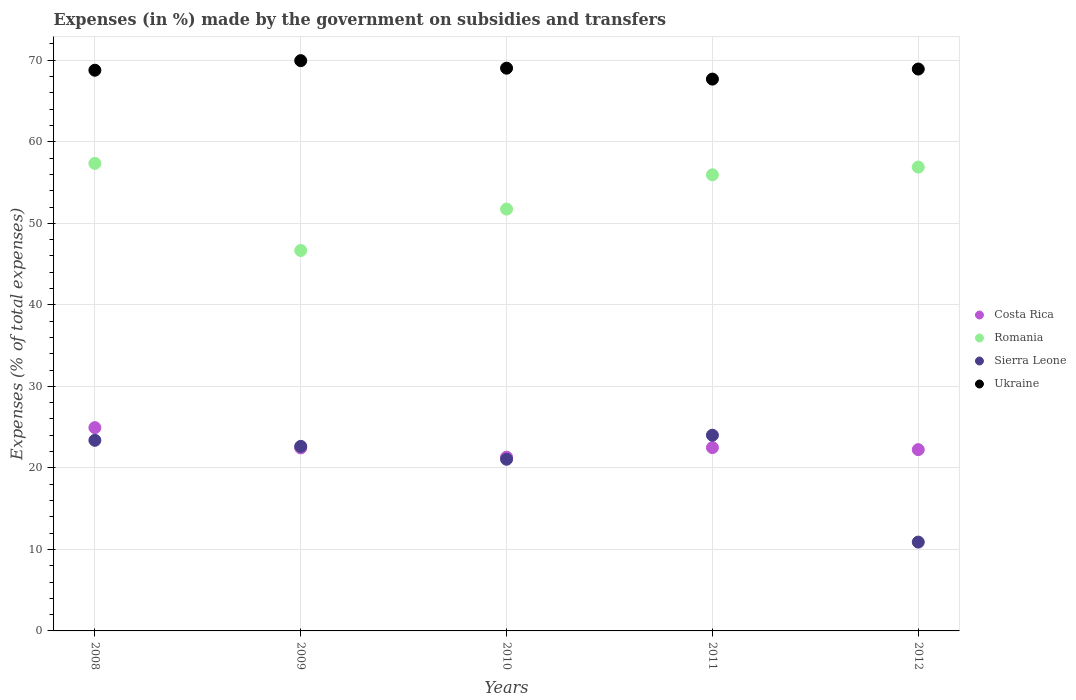What is the percentage of expenses made by the government on subsidies and transfers in Costa Rica in 2009?
Your answer should be compact. 22.45. Across all years, what is the maximum percentage of expenses made by the government on subsidies and transfers in Costa Rica?
Your answer should be compact. 24.94. Across all years, what is the minimum percentage of expenses made by the government on subsidies and transfers in Romania?
Your answer should be compact. 46.67. What is the total percentage of expenses made by the government on subsidies and transfers in Sierra Leone in the graph?
Provide a succinct answer. 101.99. What is the difference between the percentage of expenses made by the government on subsidies and transfers in Romania in 2008 and that in 2011?
Offer a terse response. 1.4. What is the difference between the percentage of expenses made by the government on subsidies and transfers in Sierra Leone in 2011 and the percentage of expenses made by the government on subsidies and transfers in Romania in 2009?
Provide a short and direct response. -22.66. What is the average percentage of expenses made by the government on subsidies and transfers in Ukraine per year?
Offer a terse response. 68.88. In the year 2012, what is the difference between the percentage of expenses made by the government on subsidies and transfers in Sierra Leone and percentage of expenses made by the government on subsidies and transfers in Romania?
Provide a short and direct response. -46. In how many years, is the percentage of expenses made by the government on subsidies and transfers in Romania greater than 14 %?
Offer a very short reply. 5. What is the ratio of the percentage of expenses made by the government on subsidies and transfers in Ukraine in 2011 to that in 2012?
Make the answer very short. 0.98. Is the percentage of expenses made by the government on subsidies and transfers in Ukraine in 2008 less than that in 2011?
Provide a short and direct response. No. What is the difference between the highest and the second highest percentage of expenses made by the government on subsidies and transfers in Sierra Leone?
Keep it short and to the point. 0.62. What is the difference between the highest and the lowest percentage of expenses made by the government on subsidies and transfers in Costa Rica?
Provide a short and direct response. 3.62. Is it the case that in every year, the sum of the percentage of expenses made by the government on subsidies and transfers in Ukraine and percentage of expenses made by the government on subsidies and transfers in Costa Rica  is greater than the sum of percentage of expenses made by the government on subsidies and transfers in Sierra Leone and percentage of expenses made by the government on subsidies and transfers in Romania?
Ensure brevity in your answer.  No. Is it the case that in every year, the sum of the percentage of expenses made by the government on subsidies and transfers in Costa Rica and percentage of expenses made by the government on subsidies and transfers in Romania  is greater than the percentage of expenses made by the government on subsidies and transfers in Ukraine?
Provide a short and direct response. No. Does the percentage of expenses made by the government on subsidies and transfers in Costa Rica monotonically increase over the years?
Your response must be concise. No. Is the percentage of expenses made by the government on subsidies and transfers in Sierra Leone strictly greater than the percentage of expenses made by the government on subsidies and transfers in Ukraine over the years?
Ensure brevity in your answer.  No. Is the percentage of expenses made by the government on subsidies and transfers in Costa Rica strictly less than the percentage of expenses made by the government on subsidies and transfers in Ukraine over the years?
Ensure brevity in your answer.  Yes. How many years are there in the graph?
Make the answer very short. 5. What is the difference between two consecutive major ticks on the Y-axis?
Your response must be concise. 10. Are the values on the major ticks of Y-axis written in scientific E-notation?
Give a very brief answer. No. Where does the legend appear in the graph?
Your answer should be very brief. Center right. What is the title of the graph?
Ensure brevity in your answer.  Expenses (in %) made by the government on subsidies and transfers. Does "Central Europe" appear as one of the legend labels in the graph?
Give a very brief answer. No. What is the label or title of the Y-axis?
Give a very brief answer. Expenses (% of total expenses). What is the Expenses (% of total expenses) in Costa Rica in 2008?
Ensure brevity in your answer.  24.94. What is the Expenses (% of total expenses) of Romania in 2008?
Offer a very short reply. 57.35. What is the Expenses (% of total expenses) of Sierra Leone in 2008?
Keep it short and to the point. 23.38. What is the Expenses (% of total expenses) of Ukraine in 2008?
Provide a short and direct response. 68.78. What is the Expenses (% of total expenses) in Costa Rica in 2009?
Your answer should be very brief. 22.45. What is the Expenses (% of total expenses) in Romania in 2009?
Give a very brief answer. 46.67. What is the Expenses (% of total expenses) in Sierra Leone in 2009?
Your response must be concise. 22.64. What is the Expenses (% of total expenses) of Ukraine in 2009?
Keep it short and to the point. 69.96. What is the Expenses (% of total expenses) in Costa Rica in 2010?
Give a very brief answer. 21.31. What is the Expenses (% of total expenses) of Romania in 2010?
Your answer should be compact. 51.75. What is the Expenses (% of total expenses) of Sierra Leone in 2010?
Give a very brief answer. 21.06. What is the Expenses (% of total expenses) in Ukraine in 2010?
Offer a very short reply. 69.03. What is the Expenses (% of total expenses) of Costa Rica in 2011?
Your response must be concise. 22.49. What is the Expenses (% of total expenses) of Romania in 2011?
Provide a short and direct response. 55.95. What is the Expenses (% of total expenses) of Sierra Leone in 2011?
Offer a very short reply. 24.01. What is the Expenses (% of total expenses) of Ukraine in 2011?
Provide a short and direct response. 67.69. What is the Expenses (% of total expenses) in Costa Rica in 2012?
Keep it short and to the point. 22.24. What is the Expenses (% of total expenses) in Romania in 2012?
Provide a short and direct response. 56.9. What is the Expenses (% of total expenses) in Sierra Leone in 2012?
Ensure brevity in your answer.  10.9. What is the Expenses (% of total expenses) of Ukraine in 2012?
Your answer should be very brief. 68.93. Across all years, what is the maximum Expenses (% of total expenses) of Costa Rica?
Provide a succinct answer. 24.94. Across all years, what is the maximum Expenses (% of total expenses) in Romania?
Ensure brevity in your answer.  57.35. Across all years, what is the maximum Expenses (% of total expenses) of Sierra Leone?
Give a very brief answer. 24.01. Across all years, what is the maximum Expenses (% of total expenses) of Ukraine?
Your answer should be compact. 69.96. Across all years, what is the minimum Expenses (% of total expenses) in Costa Rica?
Your answer should be compact. 21.31. Across all years, what is the minimum Expenses (% of total expenses) of Romania?
Offer a very short reply. 46.67. Across all years, what is the minimum Expenses (% of total expenses) of Sierra Leone?
Offer a very short reply. 10.9. Across all years, what is the minimum Expenses (% of total expenses) in Ukraine?
Provide a succinct answer. 67.69. What is the total Expenses (% of total expenses) of Costa Rica in the graph?
Make the answer very short. 113.43. What is the total Expenses (% of total expenses) in Romania in the graph?
Offer a very short reply. 268.61. What is the total Expenses (% of total expenses) of Sierra Leone in the graph?
Offer a very short reply. 101.99. What is the total Expenses (% of total expenses) in Ukraine in the graph?
Offer a very short reply. 344.38. What is the difference between the Expenses (% of total expenses) in Costa Rica in 2008 and that in 2009?
Your answer should be very brief. 2.49. What is the difference between the Expenses (% of total expenses) of Romania in 2008 and that in 2009?
Give a very brief answer. 10.68. What is the difference between the Expenses (% of total expenses) of Sierra Leone in 2008 and that in 2009?
Offer a very short reply. 0.74. What is the difference between the Expenses (% of total expenses) in Ukraine in 2008 and that in 2009?
Offer a terse response. -1.17. What is the difference between the Expenses (% of total expenses) in Costa Rica in 2008 and that in 2010?
Your answer should be very brief. 3.62. What is the difference between the Expenses (% of total expenses) in Romania in 2008 and that in 2010?
Give a very brief answer. 5.6. What is the difference between the Expenses (% of total expenses) of Sierra Leone in 2008 and that in 2010?
Keep it short and to the point. 2.32. What is the difference between the Expenses (% of total expenses) of Ukraine in 2008 and that in 2010?
Ensure brevity in your answer.  -0.25. What is the difference between the Expenses (% of total expenses) in Costa Rica in 2008 and that in 2011?
Make the answer very short. 2.45. What is the difference between the Expenses (% of total expenses) of Romania in 2008 and that in 2011?
Offer a terse response. 1.4. What is the difference between the Expenses (% of total expenses) in Sierra Leone in 2008 and that in 2011?
Your answer should be very brief. -0.62. What is the difference between the Expenses (% of total expenses) in Ukraine in 2008 and that in 2011?
Your answer should be very brief. 1.09. What is the difference between the Expenses (% of total expenses) in Costa Rica in 2008 and that in 2012?
Your answer should be compact. 2.7. What is the difference between the Expenses (% of total expenses) in Romania in 2008 and that in 2012?
Your answer should be compact. 0.45. What is the difference between the Expenses (% of total expenses) of Sierra Leone in 2008 and that in 2012?
Provide a succinct answer. 12.49. What is the difference between the Expenses (% of total expenses) in Ukraine in 2008 and that in 2012?
Ensure brevity in your answer.  -0.15. What is the difference between the Expenses (% of total expenses) of Costa Rica in 2009 and that in 2010?
Ensure brevity in your answer.  1.14. What is the difference between the Expenses (% of total expenses) in Romania in 2009 and that in 2010?
Your response must be concise. -5.08. What is the difference between the Expenses (% of total expenses) in Sierra Leone in 2009 and that in 2010?
Give a very brief answer. 1.58. What is the difference between the Expenses (% of total expenses) in Ukraine in 2009 and that in 2010?
Offer a very short reply. 0.92. What is the difference between the Expenses (% of total expenses) of Costa Rica in 2009 and that in 2011?
Your answer should be very brief. -0.04. What is the difference between the Expenses (% of total expenses) of Romania in 2009 and that in 2011?
Keep it short and to the point. -9.29. What is the difference between the Expenses (% of total expenses) of Sierra Leone in 2009 and that in 2011?
Your response must be concise. -1.36. What is the difference between the Expenses (% of total expenses) of Ukraine in 2009 and that in 2011?
Offer a very short reply. 2.26. What is the difference between the Expenses (% of total expenses) in Costa Rica in 2009 and that in 2012?
Keep it short and to the point. 0.21. What is the difference between the Expenses (% of total expenses) of Romania in 2009 and that in 2012?
Your answer should be compact. -10.23. What is the difference between the Expenses (% of total expenses) of Sierra Leone in 2009 and that in 2012?
Your response must be concise. 11.74. What is the difference between the Expenses (% of total expenses) of Ukraine in 2009 and that in 2012?
Your response must be concise. 1.03. What is the difference between the Expenses (% of total expenses) in Costa Rica in 2010 and that in 2011?
Make the answer very short. -1.17. What is the difference between the Expenses (% of total expenses) in Romania in 2010 and that in 2011?
Your answer should be very brief. -4.2. What is the difference between the Expenses (% of total expenses) of Sierra Leone in 2010 and that in 2011?
Give a very brief answer. -2.95. What is the difference between the Expenses (% of total expenses) in Ukraine in 2010 and that in 2011?
Ensure brevity in your answer.  1.34. What is the difference between the Expenses (% of total expenses) in Costa Rica in 2010 and that in 2012?
Give a very brief answer. -0.92. What is the difference between the Expenses (% of total expenses) of Romania in 2010 and that in 2012?
Your response must be concise. -5.15. What is the difference between the Expenses (% of total expenses) of Sierra Leone in 2010 and that in 2012?
Provide a succinct answer. 10.16. What is the difference between the Expenses (% of total expenses) of Ukraine in 2010 and that in 2012?
Your answer should be compact. 0.11. What is the difference between the Expenses (% of total expenses) in Costa Rica in 2011 and that in 2012?
Ensure brevity in your answer.  0.25. What is the difference between the Expenses (% of total expenses) in Romania in 2011 and that in 2012?
Make the answer very short. -0.94. What is the difference between the Expenses (% of total expenses) of Sierra Leone in 2011 and that in 2012?
Your answer should be very brief. 13.11. What is the difference between the Expenses (% of total expenses) of Ukraine in 2011 and that in 2012?
Provide a succinct answer. -1.23. What is the difference between the Expenses (% of total expenses) of Costa Rica in 2008 and the Expenses (% of total expenses) of Romania in 2009?
Offer a terse response. -21.73. What is the difference between the Expenses (% of total expenses) of Costa Rica in 2008 and the Expenses (% of total expenses) of Sierra Leone in 2009?
Your response must be concise. 2.3. What is the difference between the Expenses (% of total expenses) of Costa Rica in 2008 and the Expenses (% of total expenses) of Ukraine in 2009?
Ensure brevity in your answer.  -45.02. What is the difference between the Expenses (% of total expenses) of Romania in 2008 and the Expenses (% of total expenses) of Sierra Leone in 2009?
Your response must be concise. 34.71. What is the difference between the Expenses (% of total expenses) in Romania in 2008 and the Expenses (% of total expenses) in Ukraine in 2009?
Ensure brevity in your answer.  -12.61. What is the difference between the Expenses (% of total expenses) in Sierra Leone in 2008 and the Expenses (% of total expenses) in Ukraine in 2009?
Ensure brevity in your answer.  -46.57. What is the difference between the Expenses (% of total expenses) in Costa Rica in 2008 and the Expenses (% of total expenses) in Romania in 2010?
Provide a short and direct response. -26.81. What is the difference between the Expenses (% of total expenses) in Costa Rica in 2008 and the Expenses (% of total expenses) in Sierra Leone in 2010?
Make the answer very short. 3.88. What is the difference between the Expenses (% of total expenses) of Costa Rica in 2008 and the Expenses (% of total expenses) of Ukraine in 2010?
Provide a succinct answer. -44.09. What is the difference between the Expenses (% of total expenses) in Romania in 2008 and the Expenses (% of total expenses) in Sierra Leone in 2010?
Your answer should be very brief. 36.29. What is the difference between the Expenses (% of total expenses) in Romania in 2008 and the Expenses (% of total expenses) in Ukraine in 2010?
Provide a short and direct response. -11.68. What is the difference between the Expenses (% of total expenses) in Sierra Leone in 2008 and the Expenses (% of total expenses) in Ukraine in 2010?
Give a very brief answer. -45.65. What is the difference between the Expenses (% of total expenses) in Costa Rica in 2008 and the Expenses (% of total expenses) in Romania in 2011?
Your answer should be very brief. -31.01. What is the difference between the Expenses (% of total expenses) of Costa Rica in 2008 and the Expenses (% of total expenses) of Sierra Leone in 2011?
Keep it short and to the point. 0.93. What is the difference between the Expenses (% of total expenses) of Costa Rica in 2008 and the Expenses (% of total expenses) of Ukraine in 2011?
Provide a short and direct response. -42.75. What is the difference between the Expenses (% of total expenses) in Romania in 2008 and the Expenses (% of total expenses) in Sierra Leone in 2011?
Your answer should be very brief. 33.34. What is the difference between the Expenses (% of total expenses) in Romania in 2008 and the Expenses (% of total expenses) in Ukraine in 2011?
Make the answer very short. -10.34. What is the difference between the Expenses (% of total expenses) in Sierra Leone in 2008 and the Expenses (% of total expenses) in Ukraine in 2011?
Offer a very short reply. -44.31. What is the difference between the Expenses (% of total expenses) of Costa Rica in 2008 and the Expenses (% of total expenses) of Romania in 2012?
Keep it short and to the point. -31.96. What is the difference between the Expenses (% of total expenses) of Costa Rica in 2008 and the Expenses (% of total expenses) of Sierra Leone in 2012?
Provide a short and direct response. 14.04. What is the difference between the Expenses (% of total expenses) in Costa Rica in 2008 and the Expenses (% of total expenses) in Ukraine in 2012?
Make the answer very short. -43.99. What is the difference between the Expenses (% of total expenses) of Romania in 2008 and the Expenses (% of total expenses) of Sierra Leone in 2012?
Provide a succinct answer. 46.45. What is the difference between the Expenses (% of total expenses) in Romania in 2008 and the Expenses (% of total expenses) in Ukraine in 2012?
Your answer should be compact. -11.58. What is the difference between the Expenses (% of total expenses) in Sierra Leone in 2008 and the Expenses (% of total expenses) in Ukraine in 2012?
Offer a terse response. -45.54. What is the difference between the Expenses (% of total expenses) of Costa Rica in 2009 and the Expenses (% of total expenses) of Romania in 2010?
Make the answer very short. -29.3. What is the difference between the Expenses (% of total expenses) of Costa Rica in 2009 and the Expenses (% of total expenses) of Sierra Leone in 2010?
Your answer should be very brief. 1.39. What is the difference between the Expenses (% of total expenses) of Costa Rica in 2009 and the Expenses (% of total expenses) of Ukraine in 2010?
Provide a succinct answer. -46.58. What is the difference between the Expenses (% of total expenses) in Romania in 2009 and the Expenses (% of total expenses) in Sierra Leone in 2010?
Your answer should be very brief. 25.61. What is the difference between the Expenses (% of total expenses) in Romania in 2009 and the Expenses (% of total expenses) in Ukraine in 2010?
Your answer should be compact. -22.37. What is the difference between the Expenses (% of total expenses) in Sierra Leone in 2009 and the Expenses (% of total expenses) in Ukraine in 2010?
Ensure brevity in your answer.  -46.39. What is the difference between the Expenses (% of total expenses) in Costa Rica in 2009 and the Expenses (% of total expenses) in Romania in 2011?
Offer a very short reply. -33.5. What is the difference between the Expenses (% of total expenses) of Costa Rica in 2009 and the Expenses (% of total expenses) of Sierra Leone in 2011?
Offer a very short reply. -1.55. What is the difference between the Expenses (% of total expenses) of Costa Rica in 2009 and the Expenses (% of total expenses) of Ukraine in 2011?
Offer a terse response. -45.24. What is the difference between the Expenses (% of total expenses) in Romania in 2009 and the Expenses (% of total expenses) in Sierra Leone in 2011?
Your answer should be very brief. 22.66. What is the difference between the Expenses (% of total expenses) in Romania in 2009 and the Expenses (% of total expenses) in Ukraine in 2011?
Your response must be concise. -21.03. What is the difference between the Expenses (% of total expenses) of Sierra Leone in 2009 and the Expenses (% of total expenses) of Ukraine in 2011?
Keep it short and to the point. -45.05. What is the difference between the Expenses (% of total expenses) in Costa Rica in 2009 and the Expenses (% of total expenses) in Romania in 2012?
Your answer should be very brief. -34.45. What is the difference between the Expenses (% of total expenses) in Costa Rica in 2009 and the Expenses (% of total expenses) in Sierra Leone in 2012?
Give a very brief answer. 11.55. What is the difference between the Expenses (% of total expenses) in Costa Rica in 2009 and the Expenses (% of total expenses) in Ukraine in 2012?
Provide a short and direct response. -46.47. What is the difference between the Expenses (% of total expenses) in Romania in 2009 and the Expenses (% of total expenses) in Sierra Leone in 2012?
Ensure brevity in your answer.  35.77. What is the difference between the Expenses (% of total expenses) in Romania in 2009 and the Expenses (% of total expenses) in Ukraine in 2012?
Give a very brief answer. -22.26. What is the difference between the Expenses (% of total expenses) in Sierra Leone in 2009 and the Expenses (% of total expenses) in Ukraine in 2012?
Make the answer very short. -46.28. What is the difference between the Expenses (% of total expenses) in Costa Rica in 2010 and the Expenses (% of total expenses) in Romania in 2011?
Offer a terse response. -34.64. What is the difference between the Expenses (% of total expenses) of Costa Rica in 2010 and the Expenses (% of total expenses) of Sierra Leone in 2011?
Give a very brief answer. -2.69. What is the difference between the Expenses (% of total expenses) in Costa Rica in 2010 and the Expenses (% of total expenses) in Ukraine in 2011?
Provide a short and direct response. -46.38. What is the difference between the Expenses (% of total expenses) of Romania in 2010 and the Expenses (% of total expenses) of Sierra Leone in 2011?
Give a very brief answer. 27.74. What is the difference between the Expenses (% of total expenses) of Romania in 2010 and the Expenses (% of total expenses) of Ukraine in 2011?
Make the answer very short. -15.94. What is the difference between the Expenses (% of total expenses) of Sierra Leone in 2010 and the Expenses (% of total expenses) of Ukraine in 2011?
Give a very brief answer. -46.63. What is the difference between the Expenses (% of total expenses) of Costa Rica in 2010 and the Expenses (% of total expenses) of Romania in 2012?
Make the answer very short. -35.58. What is the difference between the Expenses (% of total expenses) in Costa Rica in 2010 and the Expenses (% of total expenses) in Sierra Leone in 2012?
Your answer should be very brief. 10.42. What is the difference between the Expenses (% of total expenses) of Costa Rica in 2010 and the Expenses (% of total expenses) of Ukraine in 2012?
Your answer should be very brief. -47.61. What is the difference between the Expenses (% of total expenses) in Romania in 2010 and the Expenses (% of total expenses) in Sierra Leone in 2012?
Offer a very short reply. 40.85. What is the difference between the Expenses (% of total expenses) of Romania in 2010 and the Expenses (% of total expenses) of Ukraine in 2012?
Provide a succinct answer. -17.18. What is the difference between the Expenses (% of total expenses) of Sierra Leone in 2010 and the Expenses (% of total expenses) of Ukraine in 2012?
Provide a short and direct response. -47.87. What is the difference between the Expenses (% of total expenses) of Costa Rica in 2011 and the Expenses (% of total expenses) of Romania in 2012?
Your response must be concise. -34.41. What is the difference between the Expenses (% of total expenses) of Costa Rica in 2011 and the Expenses (% of total expenses) of Sierra Leone in 2012?
Your answer should be very brief. 11.59. What is the difference between the Expenses (% of total expenses) of Costa Rica in 2011 and the Expenses (% of total expenses) of Ukraine in 2012?
Ensure brevity in your answer.  -46.44. What is the difference between the Expenses (% of total expenses) in Romania in 2011 and the Expenses (% of total expenses) in Sierra Leone in 2012?
Give a very brief answer. 45.06. What is the difference between the Expenses (% of total expenses) in Romania in 2011 and the Expenses (% of total expenses) in Ukraine in 2012?
Give a very brief answer. -12.97. What is the difference between the Expenses (% of total expenses) in Sierra Leone in 2011 and the Expenses (% of total expenses) in Ukraine in 2012?
Give a very brief answer. -44.92. What is the average Expenses (% of total expenses) in Costa Rica per year?
Provide a succinct answer. 22.69. What is the average Expenses (% of total expenses) of Romania per year?
Offer a very short reply. 53.72. What is the average Expenses (% of total expenses) of Sierra Leone per year?
Offer a very short reply. 20.4. What is the average Expenses (% of total expenses) in Ukraine per year?
Offer a very short reply. 68.88. In the year 2008, what is the difference between the Expenses (% of total expenses) in Costa Rica and Expenses (% of total expenses) in Romania?
Give a very brief answer. -32.41. In the year 2008, what is the difference between the Expenses (% of total expenses) of Costa Rica and Expenses (% of total expenses) of Sierra Leone?
Give a very brief answer. 1.56. In the year 2008, what is the difference between the Expenses (% of total expenses) in Costa Rica and Expenses (% of total expenses) in Ukraine?
Provide a succinct answer. -43.84. In the year 2008, what is the difference between the Expenses (% of total expenses) in Romania and Expenses (% of total expenses) in Sierra Leone?
Give a very brief answer. 33.97. In the year 2008, what is the difference between the Expenses (% of total expenses) in Romania and Expenses (% of total expenses) in Ukraine?
Your answer should be very brief. -11.43. In the year 2008, what is the difference between the Expenses (% of total expenses) of Sierra Leone and Expenses (% of total expenses) of Ukraine?
Provide a succinct answer. -45.4. In the year 2009, what is the difference between the Expenses (% of total expenses) of Costa Rica and Expenses (% of total expenses) of Romania?
Provide a short and direct response. -24.21. In the year 2009, what is the difference between the Expenses (% of total expenses) of Costa Rica and Expenses (% of total expenses) of Sierra Leone?
Your response must be concise. -0.19. In the year 2009, what is the difference between the Expenses (% of total expenses) of Costa Rica and Expenses (% of total expenses) of Ukraine?
Keep it short and to the point. -47.5. In the year 2009, what is the difference between the Expenses (% of total expenses) in Romania and Expenses (% of total expenses) in Sierra Leone?
Your answer should be compact. 24.02. In the year 2009, what is the difference between the Expenses (% of total expenses) of Romania and Expenses (% of total expenses) of Ukraine?
Offer a terse response. -23.29. In the year 2009, what is the difference between the Expenses (% of total expenses) of Sierra Leone and Expenses (% of total expenses) of Ukraine?
Ensure brevity in your answer.  -47.31. In the year 2010, what is the difference between the Expenses (% of total expenses) in Costa Rica and Expenses (% of total expenses) in Romania?
Keep it short and to the point. -30.43. In the year 2010, what is the difference between the Expenses (% of total expenses) in Costa Rica and Expenses (% of total expenses) in Sierra Leone?
Make the answer very short. 0.25. In the year 2010, what is the difference between the Expenses (% of total expenses) of Costa Rica and Expenses (% of total expenses) of Ukraine?
Offer a very short reply. -47.72. In the year 2010, what is the difference between the Expenses (% of total expenses) in Romania and Expenses (% of total expenses) in Sierra Leone?
Your answer should be very brief. 30.69. In the year 2010, what is the difference between the Expenses (% of total expenses) of Romania and Expenses (% of total expenses) of Ukraine?
Keep it short and to the point. -17.28. In the year 2010, what is the difference between the Expenses (% of total expenses) of Sierra Leone and Expenses (% of total expenses) of Ukraine?
Offer a very short reply. -47.97. In the year 2011, what is the difference between the Expenses (% of total expenses) of Costa Rica and Expenses (% of total expenses) of Romania?
Ensure brevity in your answer.  -33.46. In the year 2011, what is the difference between the Expenses (% of total expenses) of Costa Rica and Expenses (% of total expenses) of Sierra Leone?
Offer a very short reply. -1.52. In the year 2011, what is the difference between the Expenses (% of total expenses) of Costa Rica and Expenses (% of total expenses) of Ukraine?
Your response must be concise. -45.2. In the year 2011, what is the difference between the Expenses (% of total expenses) in Romania and Expenses (% of total expenses) in Sierra Leone?
Offer a very short reply. 31.95. In the year 2011, what is the difference between the Expenses (% of total expenses) of Romania and Expenses (% of total expenses) of Ukraine?
Make the answer very short. -11.74. In the year 2011, what is the difference between the Expenses (% of total expenses) in Sierra Leone and Expenses (% of total expenses) in Ukraine?
Provide a succinct answer. -43.69. In the year 2012, what is the difference between the Expenses (% of total expenses) of Costa Rica and Expenses (% of total expenses) of Romania?
Offer a very short reply. -34.66. In the year 2012, what is the difference between the Expenses (% of total expenses) of Costa Rica and Expenses (% of total expenses) of Sierra Leone?
Your answer should be compact. 11.34. In the year 2012, what is the difference between the Expenses (% of total expenses) in Costa Rica and Expenses (% of total expenses) in Ukraine?
Your answer should be very brief. -46.69. In the year 2012, what is the difference between the Expenses (% of total expenses) of Romania and Expenses (% of total expenses) of Sierra Leone?
Your answer should be compact. 46. In the year 2012, what is the difference between the Expenses (% of total expenses) in Romania and Expenses (% of total expenses) in Ukraine?
Your response must be concise. -12.03. In the year 2012, what is the difference between the Expenses (% of total expenses) of Sierra Leone and Expenses (% of total expenses) of Ukraine?
Your response must be concise. -58.03. What is the ratio of the Expenses (% of total expenses) in Costa Rica in 2008 to that in 2009?
Offer a very short reply. 1.11. What is the ratio of the Expenses (% of total expenses) of Romania in 2008 to that in 2009?
Your response must be concise. 1.23. What is the ratio of the Expenses (% of total expenses) in Sierra Leone in 2008 to that in 2009?
Your answer should be compact. 1.03. What is the ratio of the Expenses (% of total expenses) of Ukraine in 2008 to that in 2009?
Provide a succinct answer. 0.98. What is the ratio of the Expenses (% of total expenses) of Costa Rica in 2008 to that in 2010?
Your answer should be compact. 1.17. What is the ratio of the Expenses (% of total expenses) in Romania in 2008 to that in 2010?
Offer a terse response. 1.11. What is the ratio of the Expenses (% of total expenses) of Sierra Leone in 2008 to that in 2010?
Ensure brevity in your answer.  1.11. What is the ratio of the Expenses (% of total expenses) in Ukraine in 2008 to that in 2010?
Provide a short and direct response. 1. What is the ratio of the Expenses (% of total expenses) of Costa Rica in 2008 to that in 2011?
Provide a short and direct response. 1.11. What is the ratio of the Expenses (% of total expenses) of Sierra Leone in 2008 to that in 2011?
Your response must be concise. 0.97. What is the ratio of the Expenses (% of total expenses) of Ukraine in 2008 to that in 2011?
Make the answer very short. 1.02. What is the ratio of the Expenses (% of total expenses) in Costa Rica in 2008 to that in 2012?
Provide a succinct answer. 1.12. What is the ratio of the Expenses (% of total expenses) in Romania in 2008 to that in 2012?
Provide a succinct answer. 1.01. What is the ratio of the Expenses (% of total expenses) in Sierra Leone in 2008 to that in 2012?
Your answer should be very brief. 2.15. What is the ratio of the Expenses (% of total expenses) in Ukraine in 2008 to that in 2012?
Provide a succinct answer. 1. What is the ratio of the Expenses (% of total expenses) in Costa Rica in 2009 to that in 2010?
Ensure brevity in your answer.  1.05. What is the ratio of the Expenses (% of total expenses) of Romania in 2009 to that in 2010?
Give a very brief answer. 0.9. What is the ratio of the Expenses (% of total expenses) in Sierra Leone in 2009 to that in 2010?
Your answer should be compact. 1.08. What is the ratio of the Expenses (% of total expenses) in Ukraine in 2009 to that in 2010?
Keep it short and to the point. 1.01. What is the ratio of the Expenses (% of total expenses) in Costa Rica in 2009 to that in 2011?
Offer a terse response. 1. What is the ratio of the Expenses (% of total expenses) in Romania in 2009 to that in 2011?
Your answer should be very brief. 0.83. What is the ratio of the Expenses (% of total expenses) of Sierra Leone in 2009 to that in 2011?
Make the answer very short. 0.94. What is the ratio of the Expenses (% of total expenses) of Ukraine in 2009 to that in 2011?
Offer a terse response. 1.03. What is the ratio of the Expenses (% of total expenses) in Costa Rica in 2009 to that in 2012?
Your response must be concise. 1.01. What is the ratio of the Expenses (% of total expenses) of Romania in 2009 to that in 2012?
Provide a succinct answer. 0.82. What is the ratio of the Expenses (% of total expenses) in Sierra Leone in 2009 to that in 2012?
Make the answer very short. 2.08. What is the ratio of the Expenses (% of total expenses) of Ukraine in 2009 to that in 2012?
Your answer should be compact. 1.01. What is the ratio of the Expenses (% of total expenses) of Costa Rica in 2010 to that in 2011?
Offer a very short reply. 0.95. What is the ratio of the Expenses (% of total expenses) in Romania in 2010 to that in 2011?
Give a very brief answer. 0.92. What is the ratio of the Expenses (% of total expenses) of Sierra Leone in 2010 to that in 2011?
Provide a succinct answer. 0.88. What is the ratio of the Expenses (% of total expenses) in Ukraine in 2010 to that in 2011?
Provide a short and direct response. 1.02. What is the ratio of the Expenses (% of total expenses) of Costa Rica in 2010 to that in 2012?
Keep it short and to the point. 0.96. What is the ratio of the Expenses (% of total expenses) of Romania in 2010 to that in 2012?
Give a very brief answer. 0.91. What is the ratio of the Expenses (% of total expenses) of Sierra Leone in 2010 to that in 2012?
Offer a very short reply. 1.93. What is the ratio of the Expenses (% of total expenses) in Ukraine in 2010 to that in 2012?
Keep it short and to the point. 1. What is the ratio of the Expenses (% of total expenses) in Costa Rica in 2011 to that in 2012?
Your response must be concise. 1.01. What is the ratio of the Expenses (% of total expenses) in Romania in 2011 to that in 2012?
Your answer should be compact. 0.98. What is the ratio of the Expenses (% of total expenses) of Sierra Leone in 2011 to that in 2012?
Your answer should be compact. 2.2. What is the ratio of the Expenses (% of total expenses) in Ukraine in 2011 to that in 2012?
Ensure brevity in your answer.  0.98. What is the difference between the highest and the second highest Expenses (% of total expenses) in Costa Rica?
Your answer should be very brief. 2.45. What is the difference between the highest and the second highest Expenses (% of total expenses) of Romania?
Offer a very short reply. 0.45. What is the difference between the highest and the second highest Expenses (% of total expenses) of Sierra Leone?
Your answer should be compact. 0.62. What is the difference between the highest and the second highest Expenses (% of total expenses) of Ukraine?
Provide a succinct answer. 0.92. What is the difference between the highest and the lowest Expenses (% of total expenses) of Costa Rica?
Offer a terse response. 3.62. What is the difference between the highest and the lowest Expenses (% of total expenses) in Romania?
Offer a terse response. 10.68. What is the difference between the highest and the lowest Expenses (% of total expenses) in Sierra Leone?
Provide a short and direct response. 13.11. What is the difference between the highest and the lowest Expenses (% of total expenses) in Ukraine?
Your answer should be very brief. 2.26. 